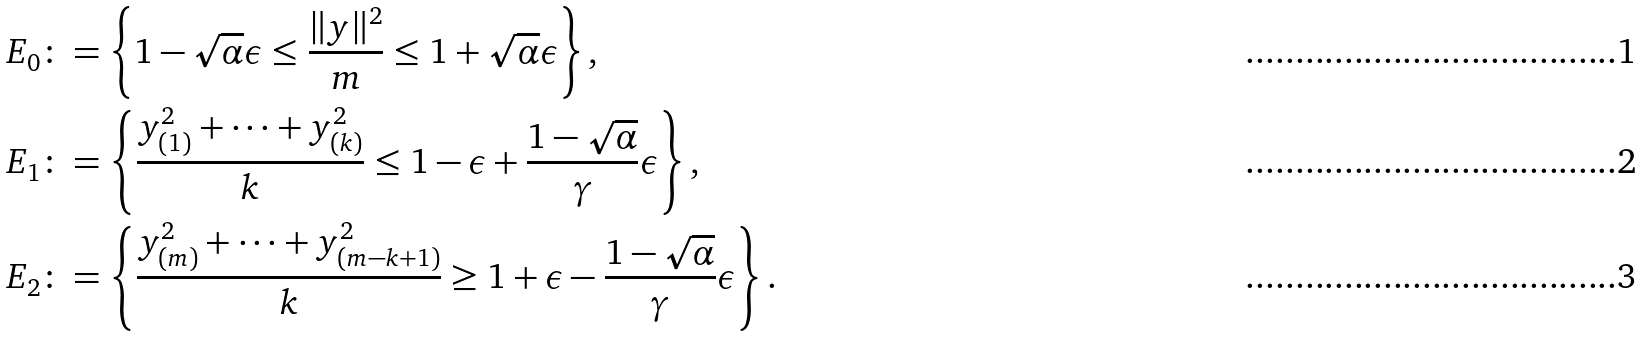Convert formula to latex. <formula><loc_0><loc_0><loc_500><loc_500>E _ { 0 } & \colon = \left \{ 1 - \sqrt { \alpha } \epsilon \leq \frac { \| y \| ^ { 2 } } { m } \leq 1 + \sqrt { \alpha } \epsilon \right \} , \\ E _ { 1 } & \colon = \left \{ \frac { y _ { ( 1 ) } ^ { 2 } + \cdots + y _ { ( k ) } ^ { 2 } } { k } \leq 1 - \epsilon + \frac { 1 - \sqrt { \alpha } } { \gamma } \epsilon \right \} , \\ E _ { 2 } & \colon = \left \{ \frac { y _ { ( m ) } ^ { 2 } + \cdots + y _ { ( m - k + 1 ) } ^ { 2 } } { k } \geq 1 + \epsilon - \frac { 1 - \sqrt { \alpha } } { \gamma } \epsilon \right \} .</formula> 